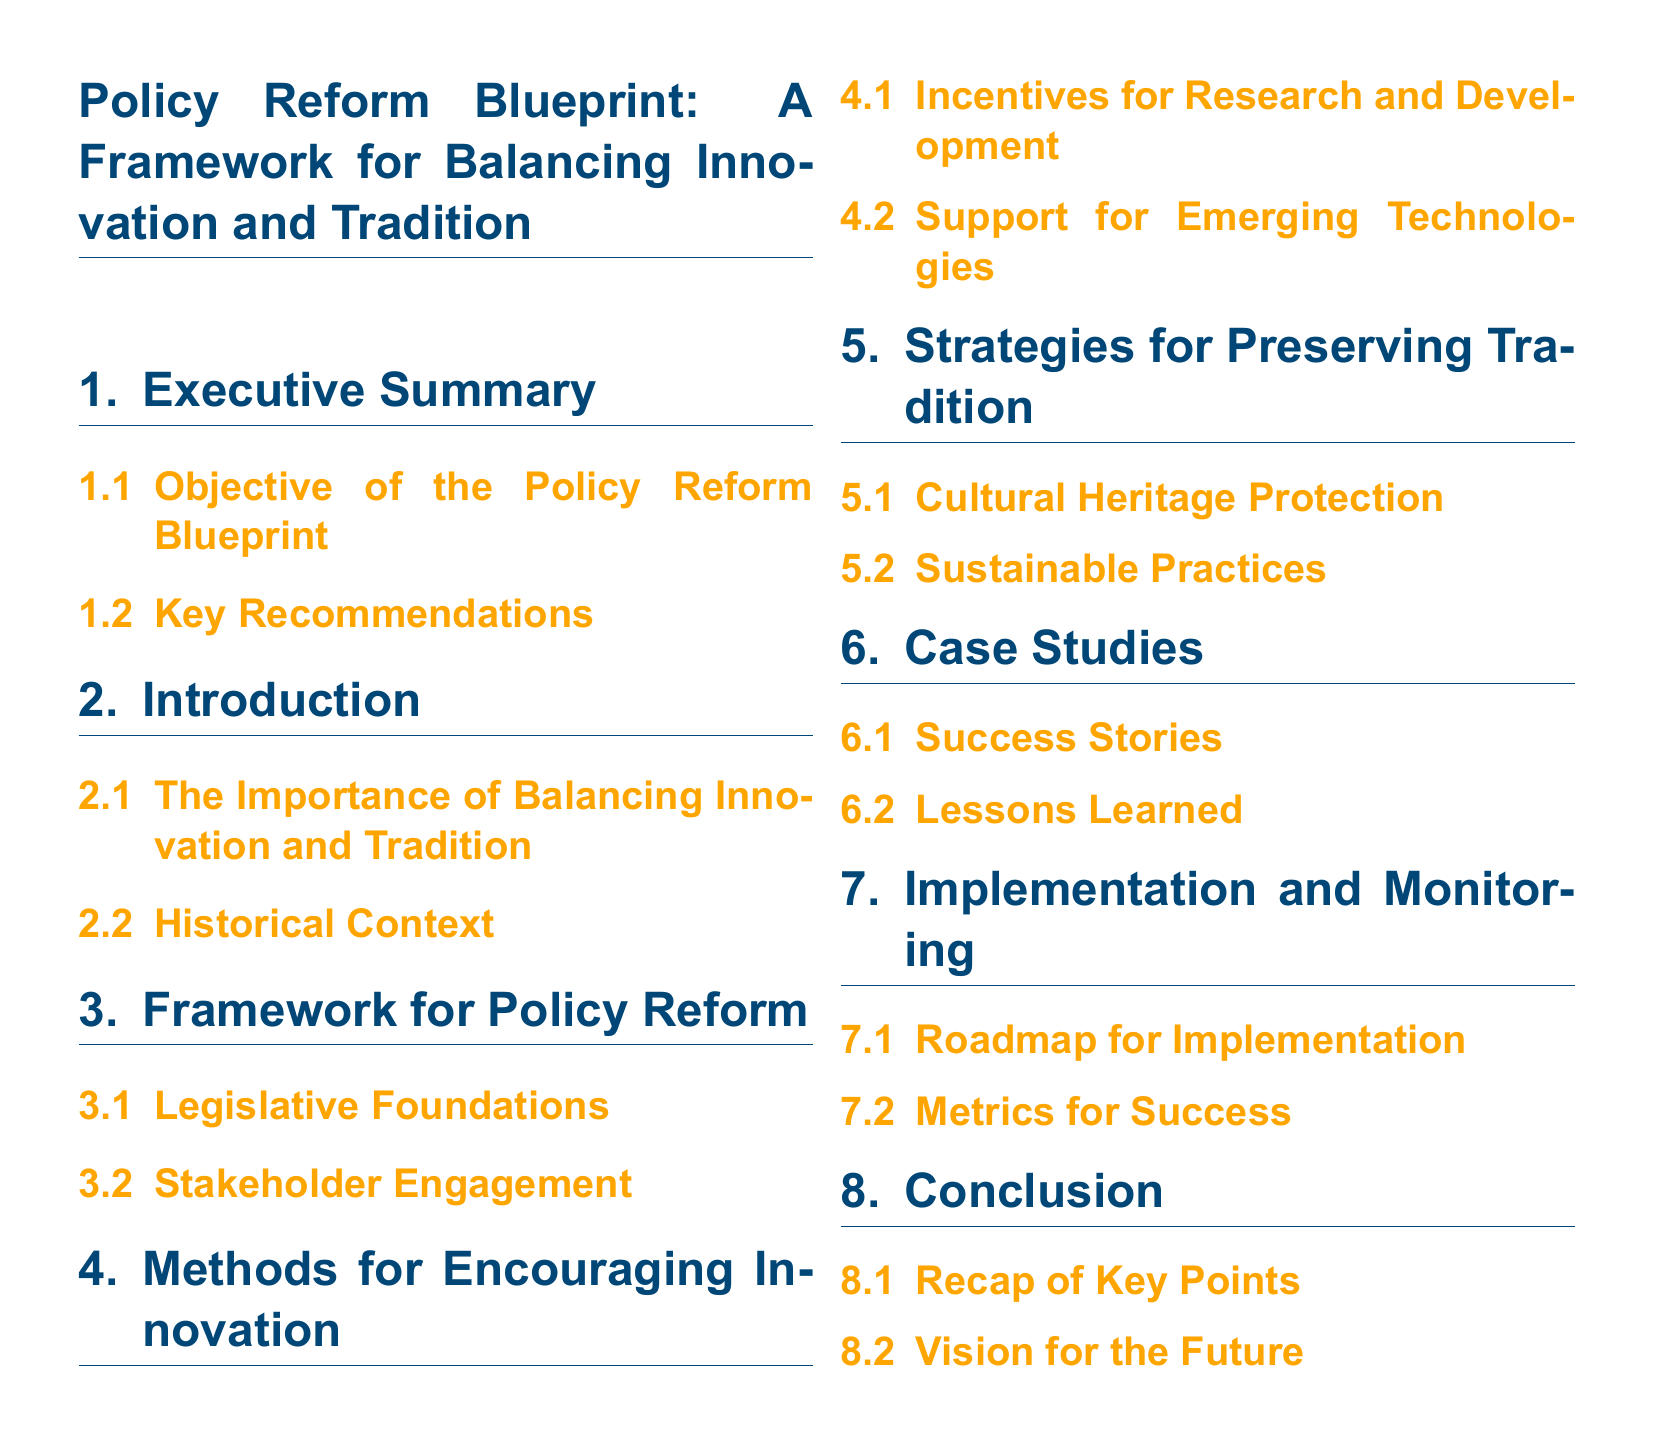What is the first section of the document? The first section is labeled as "Executive Summary," which introduces the overall content of the policy reform blueprint.
Answer: Executive Summary What does the "Introduction" section discuss? This section comprises two subsections, focusing on the balance of innovation and tradition and the historical context, setting the stage for the reform discussion.
Answer: Importance of Balancing Innovation and Tradition How many subsections are in the "Framework for Policy Reform" section? The section contains two subsections that lay out the basis for policy reform, specifically addressing legislative aspects and stakeholder involvement.
Answer: 2 What is the main focus of the subsection titled "Incentives for Research and Development"? This subsection likely describes methods and approaches to encourage innovation through funding or support mechanisms aimed at research and development initiatives.
Answer: Encouraging Innovation Which section contains "Success Stories"? This is included in the "Case Studies" section, showcasing real-world examples of effective policy reform outcomes.
Answer: Case Studies What is mentioned as part of the conclusion? The conclusion is meant to recap essential points and provide a forward-looking vision based on the findings throughout the document.
Answer: Vision for the Future What is the color used for the main title in the document? The color used for the main title features a specific RGB value, representing a dark blue tone for emphasis and visual appeal.
Answer: Dark blue What is the purpose of the "Metrics for Success" subsection? This subsection aims to establish criteria to evaluate the effectiveness and impact of the policy reform initiatives implemented.
Answer: Evaluate effectiveness How many main sections are organized in the document? The document is designed with multiple clearly defined sections that address various aspects of the policy reform topic, allowing for structured navigation.
Answer: 7 